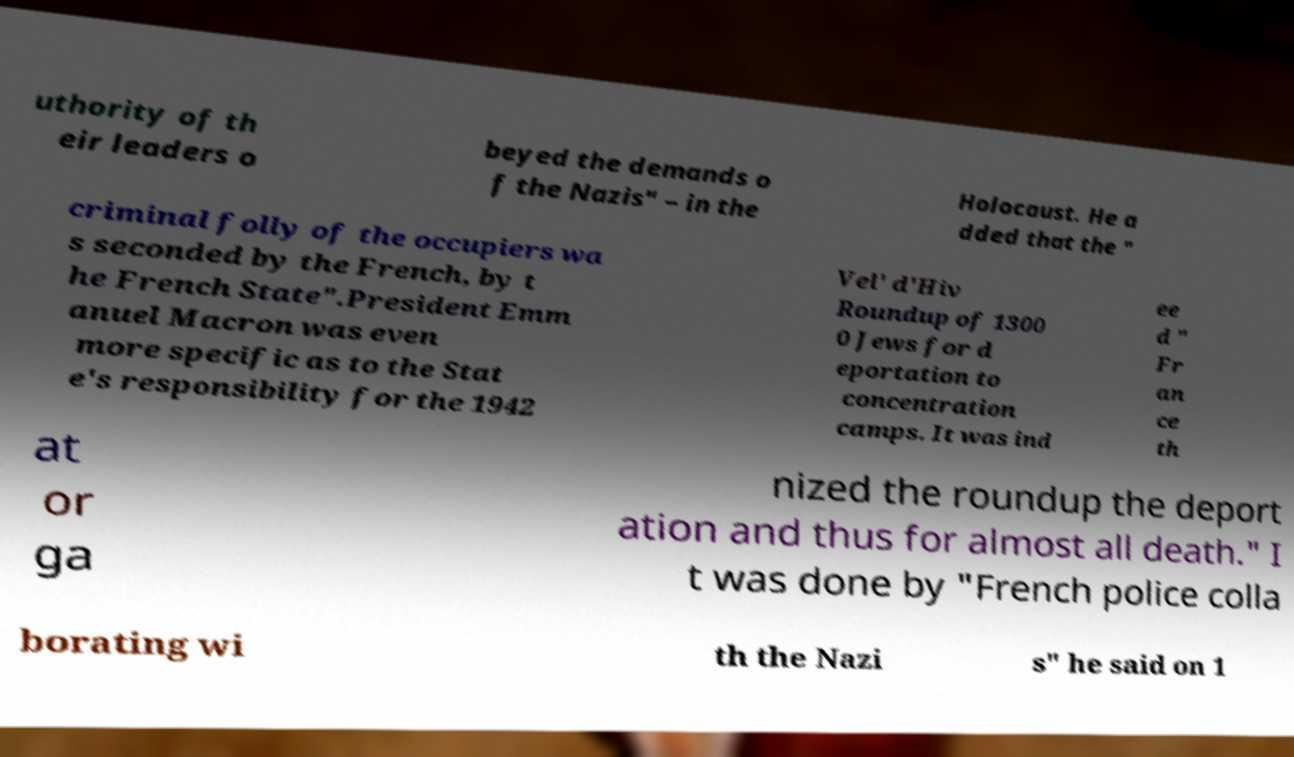Can you accurately transcribe the text from the provided image for me? uthority of th eir leaders o beyed the demands o f the Nazis" – in the Holocaust. He a dded that the " criminal folly of the occupiers wa s seconded by the French, by t he French State".President Emm anuel Macron was even more specific as to the Stat e's responsibility for the 1942 Vel' d'Hiv Roundup of 1300 0 Jews for d eportation to concentration camps. It was ind ee d " Fr an ce th at or ga nized the roundup the deport ation and thus for almost all death." I t was done by "French police colla borating wi th the Nazi s" he said on 1 